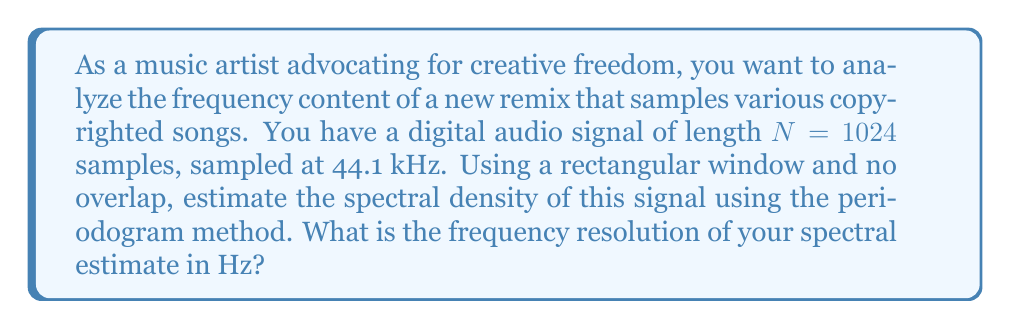Give your solution to this math problem. To solve this problem, we'll follow these steps:

1) The periodogram method estimates the spectral density of a signal using the discrete Fourier transform (DFT) of the windowed data.

2) The frequency resolution of the spectral estimate is determined by the length of the DFT and the sampling rate.

3) The frequency resolution $\Delta f$ is given by:

   $$\Delta f = \frac{f_s}{N}$$

   where $f_s$ is the sampling frequency and $N$ is the number of samples.

4) We are given:
   - Sampling frequency $f_s = 44.1$ kHz = 44100 Hz
   - Number of samples $N = 1024$

5) Substituting these values into the equation:

   $$\Delta f = \frac{44100}{1024} \approx 43.07 \text{ Hz}$$

This result represents the spacing between frequency bins in the spectral estimate, which is the finest frequency resolution achievable with this setup.
Answer: 43.07 Hz 